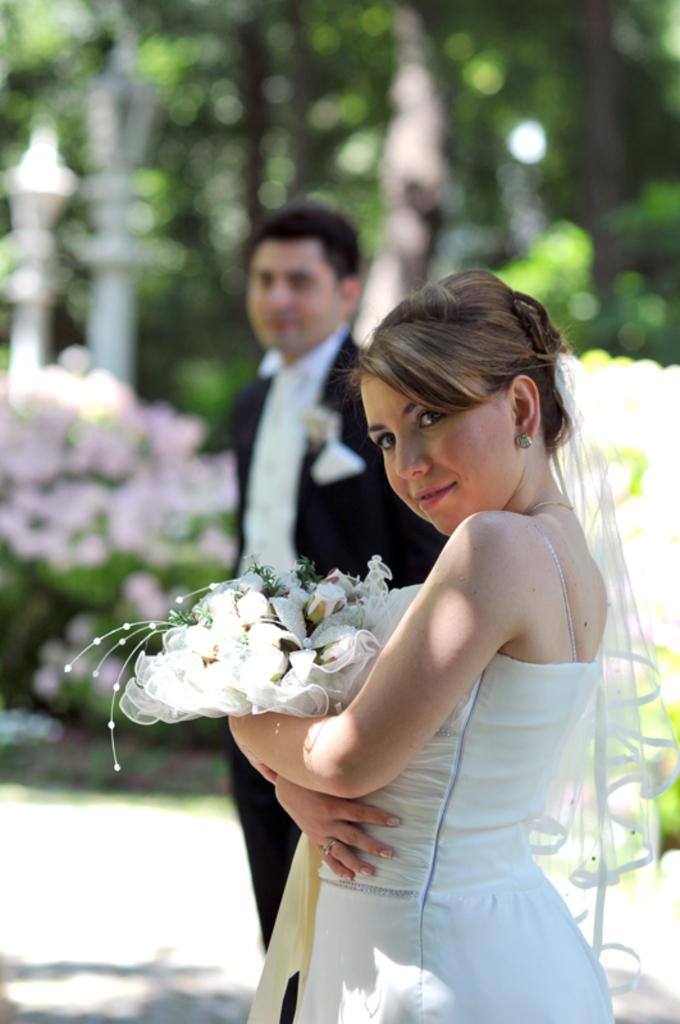How many people are present in the image? There is a man and a woman present in the image. What is the woman holding in the image? The woman is holding a flower bouquet. Can you describe the background of the image? The background of the image might include trees and poles. What type of railway can be seen in the image? There is no railway present in the image. What is the cause of the conflict between the man and the woman in the image? There is no conflict between the man and the woman in the image, nor is there any indication of a cause for such a conflict. 